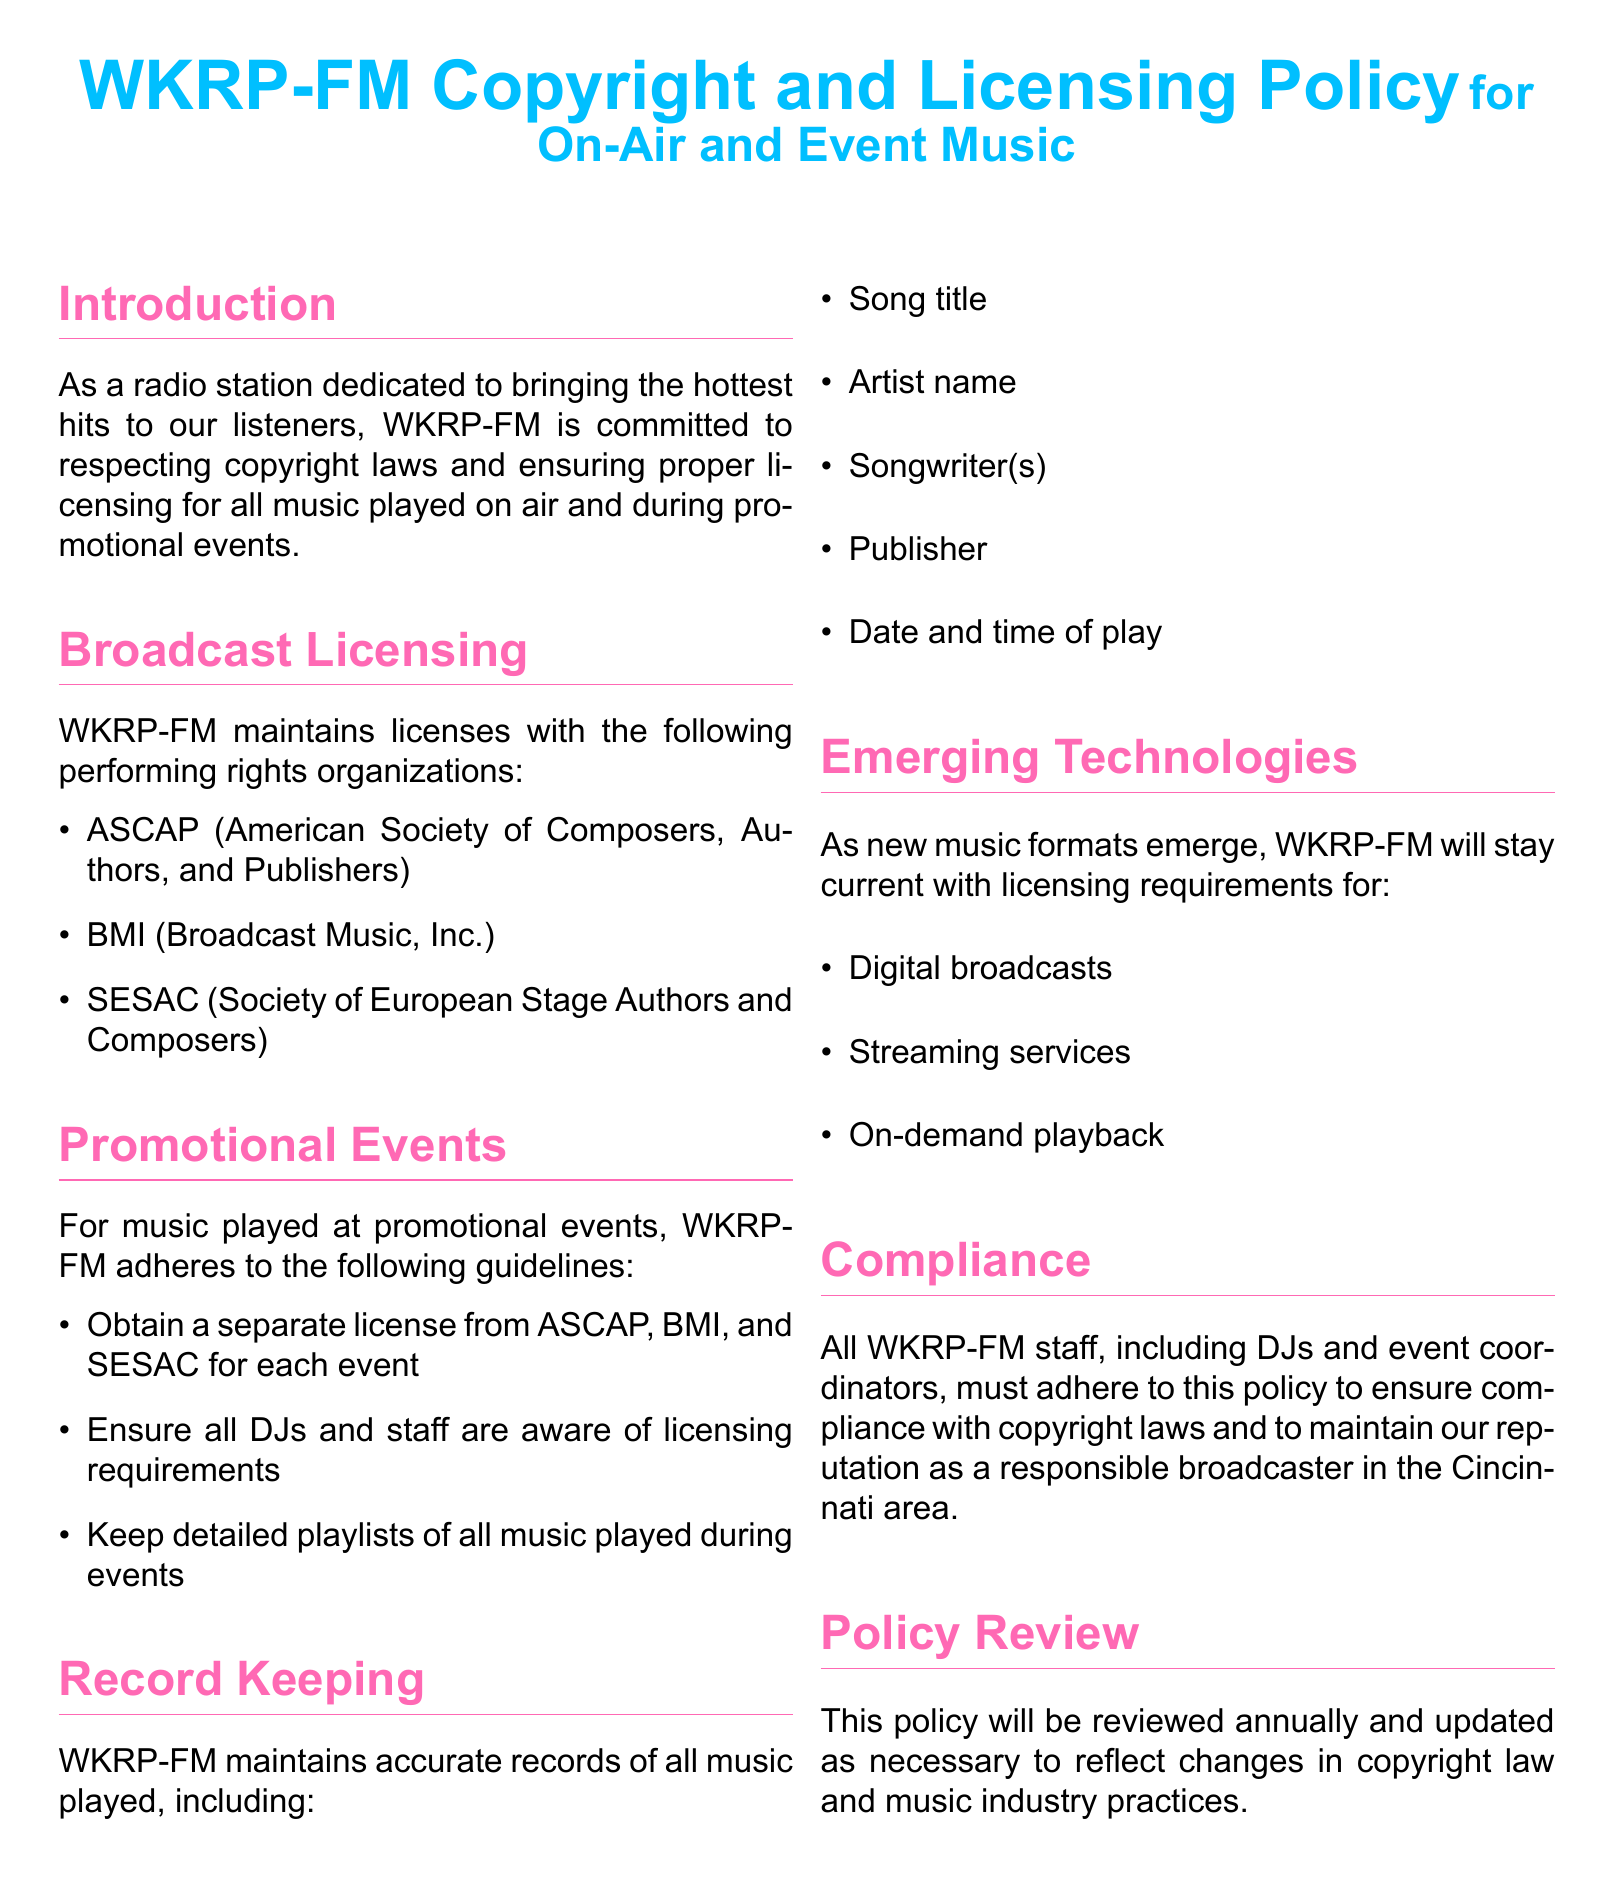What are the three performing rights organizations WKRP-FM holds licenses with? The document lists ASCAP, BMI, and SESAC as the performing rights organizations with which WKRP-FM maintains licenses.
Answer: ASCAP, BMI, SESAC What must WKRP-FM do for music played at promotional events? The document states that WKRP-FM must obtain a separate license from ASCAP, BMI, and SESAC for each event.
Answer: Obtain a separate license What record keeping details does WKRP-FM maintain? The document specifies that WKRP-FM keeps detailed records including song title, artist name, songwriter(s), publisher, and date and time of play.
Answer: Song title, artist name, songwriter(s), publisher, date and time of play How often will the policy be reviewed? The document mentions that the policy will be reviewed annually and updated as necessary.
Answer: Annually What does WKRP-FM commit to in the introduction? In the introduction, WKRP-FM commits to respecting copyright laws and ensuring proper licensing for all music played.
Answer: Respecting copyright laws What is the color of the section titles used in the document? The document specifies that section titles are in the color defined as eightiespink.
Answer: Eightiespink 